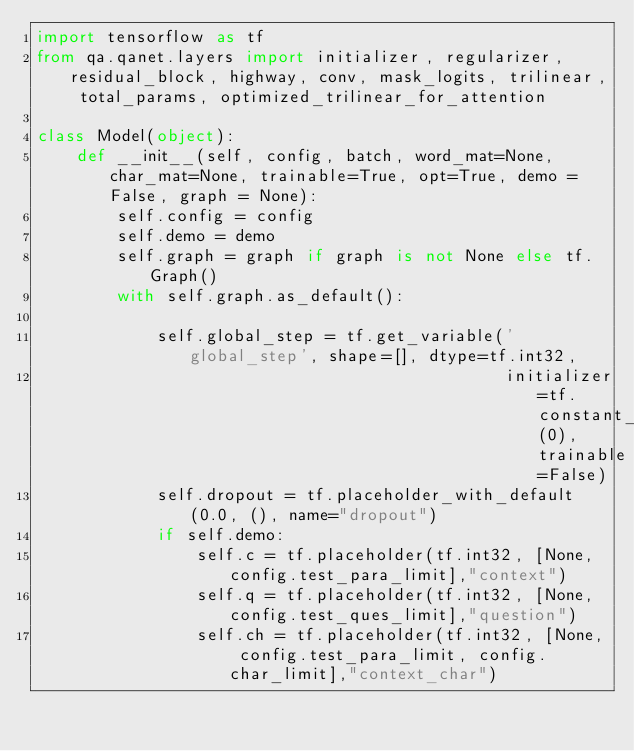Convert code to text. <code><loc_0><loc_0><loc_500><loc_500><_Python_>import tensorflow as tf
from qa.qanet.layers import initializer, regularizer, residual_block, highway, conv, mask_logits, trilinear, total_params, optimized_trilinear_for_attention

class Model(object):
    def __init__(self, config, batch, word_mat=None, char_mat=None, trainable=True, opt=True, demo = False, graph = None):
        self.config = config
        self.demo = demo
        self.graph = graph if graph is not None else tf.Graph()
        with self.graph.as_default():

            self.global_step = tf.get_variable('global_step', shape=[], dtype=tf.int32,
                                               initializer=tf.constant_initializer(0), trainable=False)
            self.dropout = tf.placeholder_with_default(0.0, (), name="dropout")
            if self.demo:
                self.c = tf.placeholder(tf.int32, [None, config.test_para_limit],"context")
                self.q = tf.placeholder(tf.int32, [None, config.test_ques_limit],"question")
                self.ch = tf.placeholder(tf.int32, [None, config.test_para_limit, config.char_limit],"context_char")</code> 